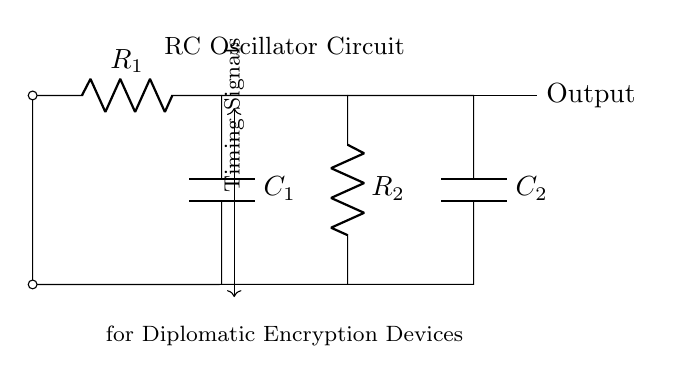What is the main function of this circuit? This circuit is designed to generate timing signals, which are essential for synchronization in various electronic applications. The presence of resistors and capacitors indicates that it operates based on charging and discharging cycles, making it effective for timing purposes.
Answer: Timing signals How many resistors are in the circuit? The circuit contains two resistors, labeled as R1 and R2. They are essential for controlling the charge and discharge times of the connected capacitors, influencing the frequency of oscillation.
Answer: Two What is the value of the capacitor connected at the output? The capacitor connected at the output is labeled C2, and its value is specific to its designation in the circuit. Capacitor values typically have unit designations (like microfarads) based on the specified documentation. However, the specific value isn't provided in the visual information.
Answer: C2 What type of circuit is this? This is an RC oscillator circuit. It comprises resistors and capacitors that work together to create oscillating signals. The naming denotes its reliance on resistive and capacitive elements to generate the desired timing function.
Answer: RC oscillator How does the signal oscillate in this circuit? The oscillation occurs because the capacitors charge through the resistors, then discharge when they reach a certain voltage level, creating a periodic signal. This cycle of charging and discharging is fundamental to how oscillators function, generating waveforms suitable for timing signals.
Answer: Periodic signal What is the output designation in the circuit? The output designation is labeled simply as "Output." This indicates the point where the generated oscillating signal can be extracted for relay to other devices or systems within diplomatic encryption devices.
Answer: Output 